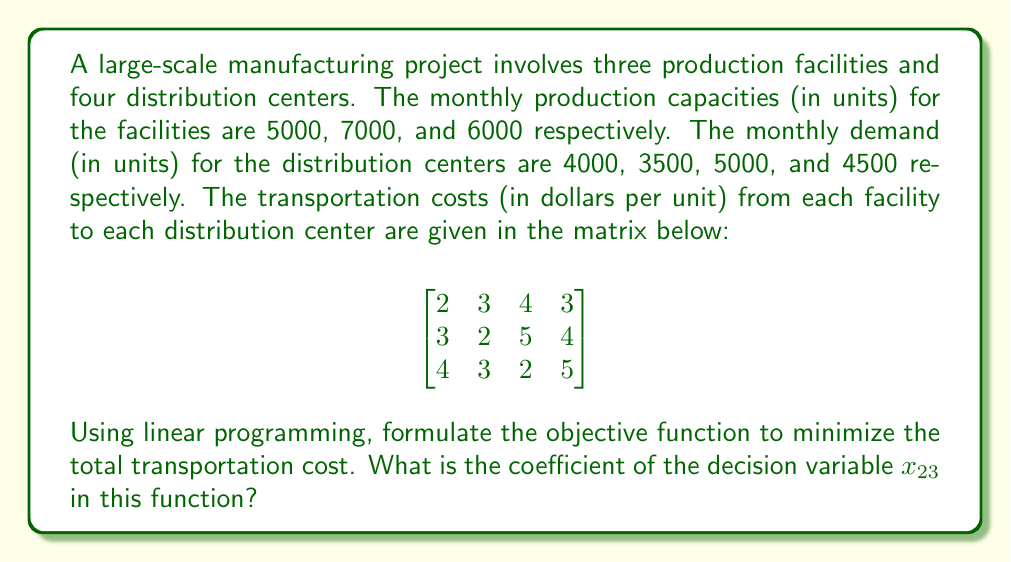Solve this math problem. To solve this problem, we need to follow these steps:

1) First, let's define our decision variables. Let $x_{ij}$ represent the number of units transported from facility $i$ to distribution center $j$.

2) The objective function in a linear programming model for minimizing transportation costs is of the form:

   $$\text{Minimize } Z = \sum_{i=1}^m \sum_{j=1}^n c_{ij}x_{ij}$$

   where $c_{ij}$ is the cost of transporting one unit from facility $i$ to distribution center $j$, and $m$ and $n$ are the number of facilities and distribution centers respectively.

3) In our case, $m = 3$ and $n = 4$. The objective function will be:

   $$Z = 2x_{11} + 3x_{12} + 4x_{13} + 3x_{14} + 3x_{21} + 2x_{22} + 5x_{23} + 4x_{24} + 4x_{31} + 3x_{32} + 2x_{33} + 5x_{34}$$

4) The question asks specifically about the coefficient of $x_{23}$. This represents the cost of transporting one unit from facility 2 to distribution center 3.

5) Looking at the cost matrix provided, we can see that the element in the 2nd row and 3rd column is 5.

Therefore, the coefficient of $x_{23}$ in the objective function is 5.
Answer: 5 